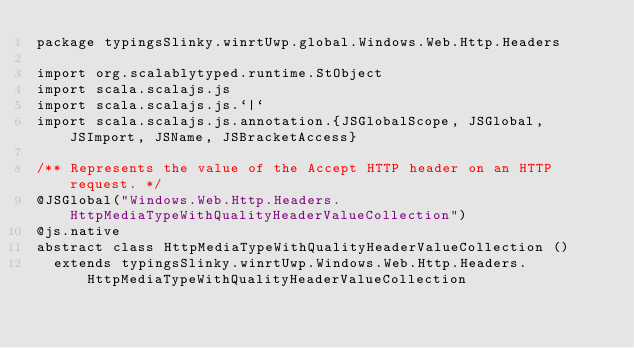Convert code to text. <code><loc_0><loc_0><loc_500><loc_500><_Scala_>package typingsSlinky.winrtUwp.global.Windows.Web.Http.Headers

import org.scalablytyped.runtime.StObject
import scala.scalajs.js
import scala.scalajs.js.`|`
import scala.scalajs.js.annotation.{JSGlobalScope, JSGlobal, JSImport, JSName, JSBracketAccess}

/** Represents the value of the Accept HTTP header on an HTTP request. */
@JSGlobal("Windows.Web.Http.Headers.HttpMediaTypeWithQualityHeaderValueCollection")
@js.native
abstract class HttpMediaTypeWithQualityHeaderValueCollection ()
  extends typingsSlinky.winrtUwp.Windows.Web.Http.Headers.HttpMediaTypeWithQualityHeaderValueCollection
</code> 